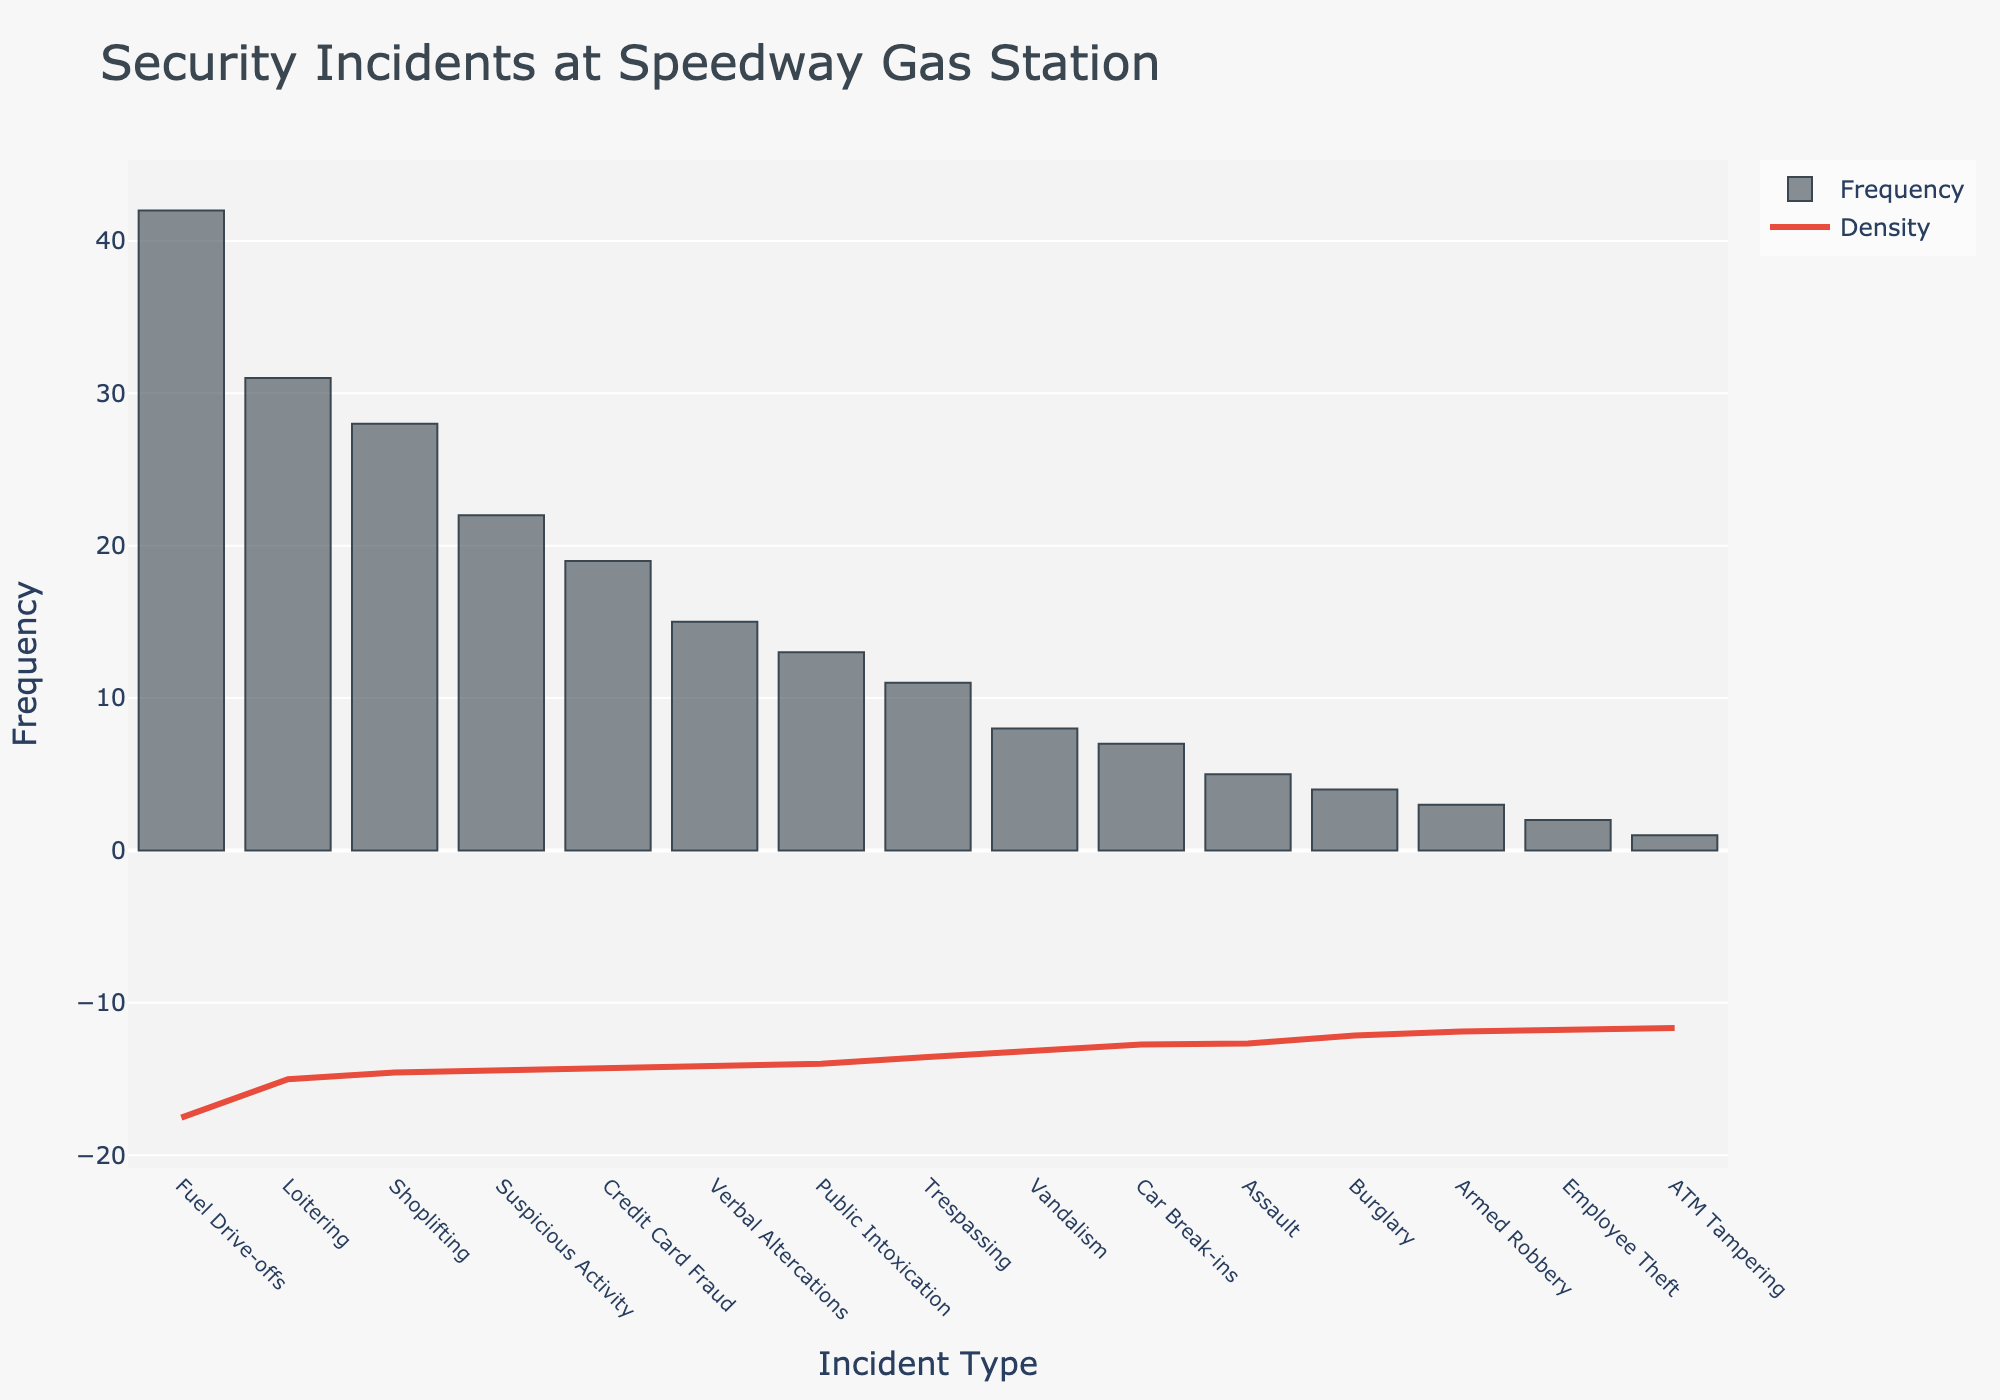what is the title of the figure? The title is located at the top of the figure. It provides a summary of what the figure represents. According to the title, this chart shows the frequency of different types of security incidents at the Speedway Gas Station over the past year.
Answer: Security Incidents at Speedway Gas Station What is the most frequent type of security incident reported? To find the most frequent incident, look for the highest bar in the histogram. According to the histogram, "Fuel Drive-offs" has the highest frequency.
Answer: Fuel Drive-offs Which incident type has the lowest frequency? Look for the shortest bar in the histogram. The shortest bar corresponds to the "ATM Tampering" incident type.
Answer: ATM Tampering How many incident types have a frequency greater than 20? Count the number of bars in the histogram that have a height greater than 20 units. Incidents that fit this criteria are Shoplifting, Fuel Drive-offs, Loitering, Suspicious Activity.
Answer: Four Is the frequency of "Assault" higher or lower than "Vandalism"? Locate the bars for "Assault" and "Vandalism" and compare their heights. The bar for "Assault" is shorter than "Vandalism," indicating a lower frequency.
Answer: Lower What is the combined frequency of "Assault" and "Burglary"? To find the combined frequency, add the frequencies of "Assault" and "Burglary" together. From the histogram, "Assault" has a frequency of 5 and "Burglary" has a frequency of 4. The combined total is 9.
Answer: 9 Which incident types fall between the frequencies of 10 and 20? Identify bars whose height falls within this range. The incident types that fit are "Credit Card Fraud" (19), "Verbal Altercations" (15), "Trespassing" (11), and "Public Intoxication" (13).
Answer: Credit Card Fraud, Verbal Altercations, Trespassing, Public Intoxication Which incident type has a frequency closest to the average frequency across all types? First, calculate the average frequency by summing all the frequencies and dividing by the total number of incident types (15). Then find the frequency closest to this average. Sum of frequencies: 28+42+15+3+8+19+2+5+31+11+1+4+13+7+22 = 211. Average = 211/15 ≈ 14.07. The closest frequency to 14.07 is Public Intoxication at 13.
Answer: Public Intoxication How does the density curve relate to the frequency of incidents? The KDE curve provides a smooth estimate of the data's distribution. Areas under high bars in the histogram will correspond to peaks in the KDE curve, indicating higher frequency incidents. The KDE curve helps visualize the overall distribution of incident frequencies.
Answer: It shows the overall distribution Which incident types contribute to the peak of the KDE curve? Observe the KDE curve's peak and check which bars (incident types) fall under this peak. The peak corresponds to high-frequency incidents like Fuel Drive-offs, Loitering, and Shoplifting.
Answer: Fuel Drive-offs, Loitering, Shoplifting 